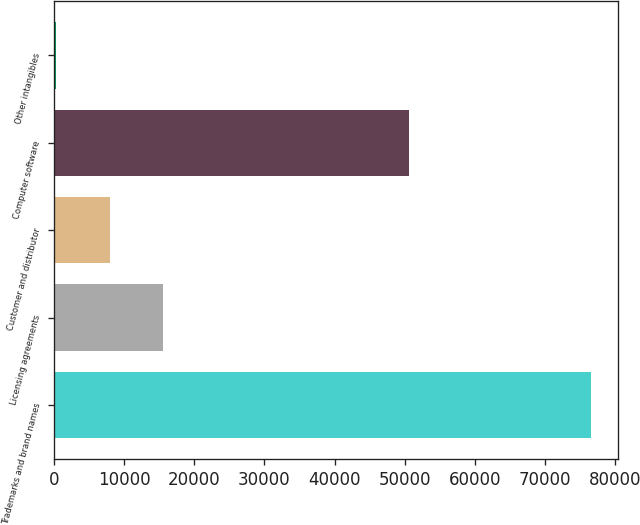Convert chart to OTSL. <chart><loc_0><loc_0><loc_500><loc_500><bar_chart><fcel>Trademarks and brand names<fcel>Licensing agreements<fcel>Customer and distributor<fcel>Computer software<fcel>Other intangibles<nl><fcel>76606<fcel>15589.2<fcel>7962.1<fcel>50556<fcel>335<nl></chart> 